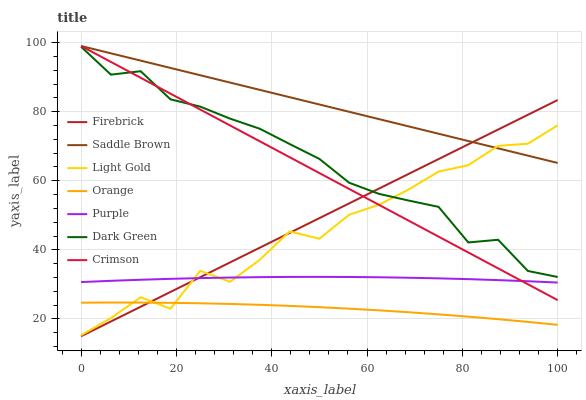Does Orange have the minimum area under the curve?
Answer yes or no. Yes. Does Saddle Brown have the maximum area under the curve?
Answer yes or no. Yes. Does Firebrick have the minimum area under the curve?
Answer yes or no. No. Does Firebrick have the maximum area under the curve?
Answer yes or no. No. Is Crimson the smoothest?
Answer yes or no. Yes. Is Light Gold the roughest?
Answer yes or no. Yes. Is Firebrick the smoothest?
Answer yes or no. No. Is Firebrick the roughest?
Answer yes or no. No. Does Firebrick have the lowest value?
Answer yes or no. Yes. Does Crimson have the lowest value?
Answer yes or no. No. Does Saddle Brown have the highest value?
Answer yes or no. Yes. Does Firebrick have the highest value?
Answer yes or no. No. Is Purple less than Saddle Brown?
Answer yes or no. Yes. Is Dark Green greater than Purple?
Answer yes or no. Yes. Does Saddle Brown intersect Crimson?
Answer yes or no. Yes. Is Saddle Brown less than Crimson?
Answer yes or no. No. Is Saddle Brown greater than Crimson?
Answer yes or no. No. Does Purple intersect Saddle Brown?
Answer yes or no. No. 